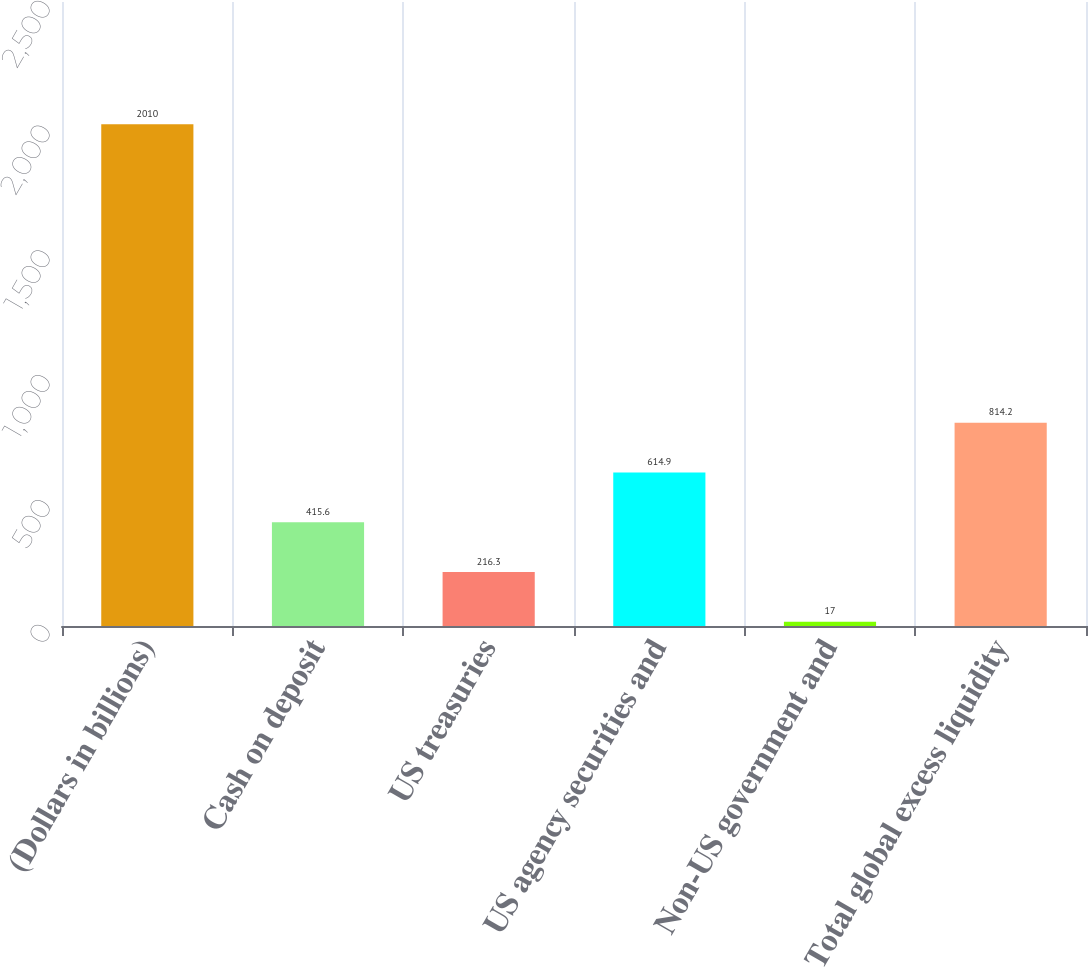Convert chart to OTSL. <chart><loc_0><loc_0><loc_500><loc_500><bar_chart><fcel>(Dollars in billions)<fcel>Cash on deposit<fcel>US treasuries<fcel>US agency securities and<fcel>Non-US government and<fcel>Total global excess liquidity<nl><fcel>2010<fcel>415.6<fcel>216.3<fcel>614.9<fcel>17<fcel>814.2<nl></chart> 